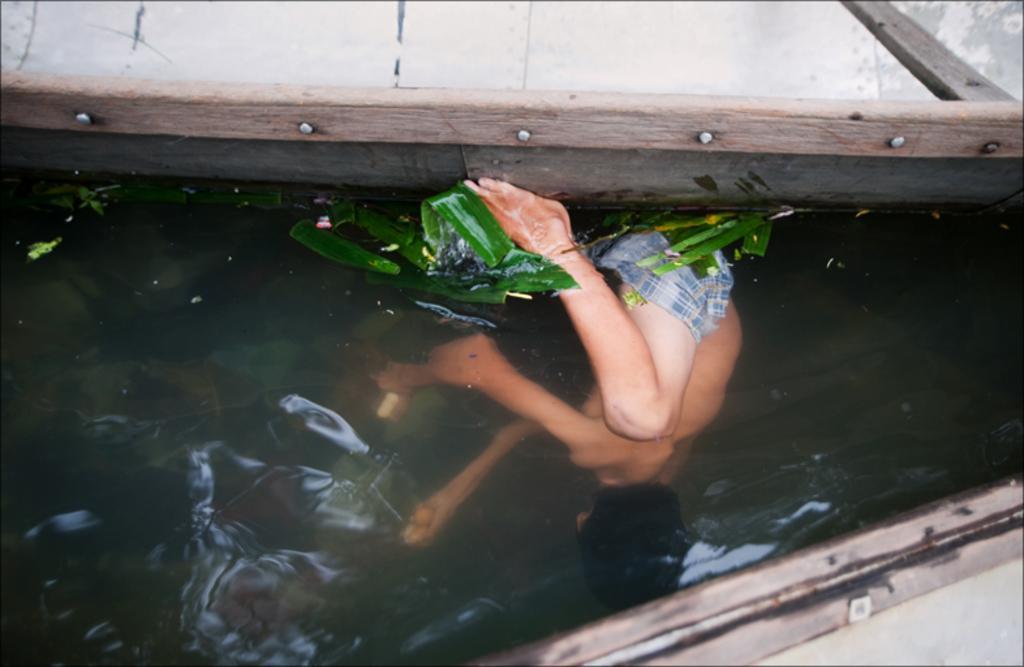How would you summarize this image in a sentence or two? Here I can see a person inside the water. On the water few leaves are visible. In the bottom right there is an object on the water. At the top of the image there is a wooden object which seems to be a boat. 